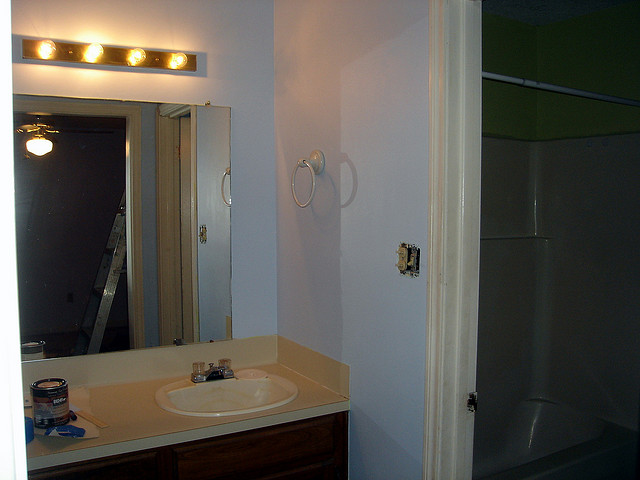<image>What brand of cleaning supplies are shown? There are no cleaning supplies visible in the image. However, it could be 'fabuloso', 'drano' or 'comet' if any. What brand of cleaning supplies are shown? There are no cleaning supplies visible in the image. 